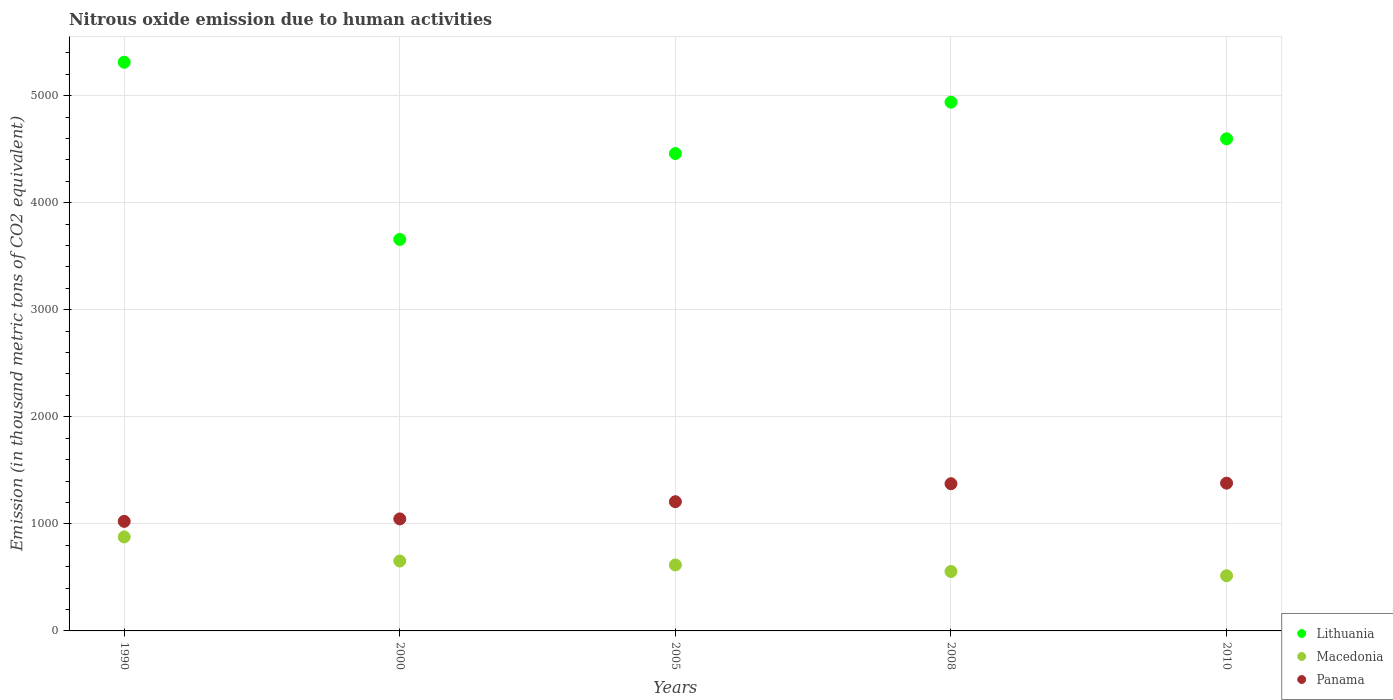Is the number of dotlines equal to the number of legend labels?
Give a very brief answer. Yes. What is the amount of nitrous oxide emitted in Panama in 2008?
Provide a short and direct response. 1375. Across all years, what is the maximum amount of nitrous oxide emitted in Macedonia?
Offer a terse response. 877.9. Across all years, what is the minimum amount of nitrous oxide emitted in Lithuania?
Keep it short and to the point. 3657. In which year was the amount of nitrous oxide emitted in Macedonia maximum?
Give a very brief answer. 1990. In which year was the amount of nitrous oxide emitted in Lithuania minimum?
Your response must be concise. 2000. What is the total amount of nitrous oxide emitted in Panama in the graph?
Your answer should be very brief. 6032.2. What is the difference between the amount of nitrous oxide emitted in Panama in 1990 and the amount of nitrous oxide emitted in Macedonia in 2010?
Your answer should be very brief. 507.7. What is the average amount of nitrous oxide emitted in Panama per year?
Your response must be concise. 1206.44. In the year 2000, what is the difference between the amount of nitrous oxide emitted in Lithuania and amount of nitrous oxide emitted in Macedonia?
Provide a succinct answer. 3004.2. What is the ratio of the amount of nitrous oxide emitted in Macedonia in 2000 to that in 2008?
Give a very brief answer. 1.18. Is the amount of nitrous oxide emitted in Macedonia in 1990 less than that in 2010?
Offer a terse response. No. What is the difference between the highest and the second highest amount of nitrous oxide emitted in Panama?
Your answer should be compact. 5.4. What is the difference between the highest and the lowest amount of nitrous oxide emitted in Macedonia?
Your answer should be compact. 362.3. In how many years, is the amount of nitrous oxide emitted in Panama greater than the average amount of nitrous oxide emitted in Panama taken over all years?
Your response must be concise. 3. Is it the case that in every year, the sum of the amount of nitrous oxide emitted in Macedonia and amount of nitrous oxide emitted in Panama  is greater than the amount of nitrous oxide emitted in Lithuania?
Your answer should be very brief. No. Is the amount of nitrous oxide emitted in Panama strictly greater than the amount of nitrous oxide emitted in Macedonia over the years?
Your response must be concise. Yes. How many dotlines are there?
Offer a terse response. 3. Does the graph contain any zero values?
Offer a very short reply. No. Does the graph contain grids?
Provide a succinct answer. Yes. How many legend labels are there?
Your response must be concise. 3. How are the legend labels stacked?
Your answer should be very brief. Vertical. What is the title of the graph?
Keep it short and to the point. Nitrous oxide emission due to human activities. What is the label or title of the Y-axis?
Your answer should be compact. Emission (in thousand metric tons of CO2 equivalent). What is the Emission (in thousand metric tons of CO2 equivalent) of Lithuania in 1990?
Your answer should be very brief. 5312.1. What is the Emission (in thousand metric tons of CO2 equivalent) in Macedonia in 1990?
Make the answer very short. 877.9. What is the Emission (in thousand metric tons of CO2 equivalent) in Panama in 1990?
Your answer should be very brief. 1023.3. What is the Emission (in thousand metric tons of CO2 equivalent) in Lithuania in 2000?
Keep it short and to the point. 3657. What is the Emission (in thousand metric tons of CO2 equivalent) of Macedonia in 2000?
Make the answer very short. 652.8. What is the Emission (in thousand metric tons of CO2 equivalent) in Panama in 2000?
Provide a succinct answer. 1046.4. What is the Emission (in thousand metric tons of CO2 equivalent) in Lithuania in 2005?
Provide a short and direct response. 4459.4. What is the Emission (in thousand metric tons of CO2 equivalent) of Macedonia in 2005?
Make the answer very short. 616.1. What is the Emission (in thousand metric tons of CO2 equivalent) of Panama in 2005?
Make the answer very short. 1207.1. What is the Emission (in thousand metric tons of CO2 equivalent) in Lithuania in 2008?
Keep it short and to the point. 4939.2. What is the Emission (in thousand metric tons of CO2 equivalent) in Macedonia in 2008?
Offer a very short reply. 555.1. What is the Emission (in thousand metric tons of CO2 equivalent) in Panama in 2008?
Your answer should be very brief. 1375. What is the Emission (in thousand metric tons of CO2 equivalent) in Lithuania in 2010?
Make the answer very short. 4596.8. What is the Emission (in thousand metric tons of CO2 equivalent) in Macedonia in 2010?
Offer a very short reply. 515.6. What is the Emission (in thousand metric tons of CO2 equivalent) of Panama in 2010?
Your answer should be very brief. 1380.4. Across all years, what is the maximum Emission (in thousand metric tons of CO2 equivalent) in Lithuania?
Make the answer very short. 5312.1. Across all years, what is the maximum Emission (in thousand metric tons of CO2 equivalent) in Macedonia?
Your response must be concise. 877.9. Across all years, what is the maximum Emission (in thousand metric tons of CO2 equivalent) in Panama?
Keep it short and to the point. 1380.4. Across all years, what is the minimum Emission (in thousand metric tons of CO2 equivalent) of Lithuania?
Provide a short and direct response. 3657. Across all years, what is the minimum Emission (in thousand metric tons of CO2 equivalent) in Macedonia?
Your response must be concise. 515.6. Across all years, what is the minimum Emission (in thousand metric tons of CO2 equivalent) in Panama?
Provide a short and direct response. 1023.3. What is the total Emission (in thousand metric tons of CO2 equivalent) of Lithuania in the graph?
Your answer should be compact. 2.30e+04. What is the total Emission (in thousand metric tons of CO2 equivalent) of Macedonia in the graph?
Offer a terse response. 3217.5. What is the total Emission (in thousand metric tons of CO2 equivalent) in Panama in the graph?
Offer a terse response. 6032.2. What is the difference between the Emission (in thousand metric tons of CO2 equivalent) of Lithuania in 1990 and that in 2000?
Offer a very short reply. 1655.1. What is the difference between the Emission (in thousand metric tons of CO2 equivalent) in Macedonia in 1990 and that in 2000?
Provide a succinct answer. 225.1. What is the difference between the Emission (in thousand metric tons of CO2 equivalent) in Panama in 1990 and that in 2000?
Offer a terse response. -23.1. What is the difference between the Emission (in thousand metric tons of CO2 equivalent) in Lithuania in 1990 and that in 2005?
Provide a succinct answer. 852.7. What is the difference between the Emission (in thousand metric tons of CO2 equivalent) of Macedonia in 1990 and that in 2005?
Offer a very short reply. 261.8. What is the difference between the Emission (in thousand metric tons of CO2 equivalent) of Panama in 1990 and that in 2005?
Offer a terse response. -183.8. What is the difference between the Emission (in thousand metric tons of CO2 equivalent) of Lithuania in 1990 and that in 2008?
Offer a terse response. 372.9. What is the difference between the Emission (in thousand metric tons of CO2 equivalent) of Macedonia in 1990 and that in 2008?
Ensure brevity in your answer.  322.8. What is the difference between the Emission (in thousand metric tons of CO2 equivalent) in Panama in 1990 and that in 2008?
Your response must be concise. -351.7. What is the difference between the Emission (in thousand metric tons of CO2 equivalent) of Lithuania in 1990 and that in 2010?
Provide a short and direct response. 715.3. What is the difference between the Emission (in thousand metric tons of CO2 equivalent) in Macedonia in 1990 and that in 2010?
Offer a terse response. 362.3. What is the difference between the Emission (in thousand metric tons of CO2 equivalent) in Panama in 1990 and that in 2010?
Ensure brevity in your answer.  -357.1. What is the difference between the Emission (in thousand metric tons of CO2 equivalent) of Lithuania in 2000 and that in 2005?
Provide a short and direct response. -802.4. What is the difference between the Emission (in thousand metric tons of CO2 equivalent) in Macedonia in 2000 and that in 2005?
Your answer should be very brief. 36.7. What is the difference between the Emission (in thousand metric tons of CO2 equivalent) in Panama in 2000 and that in 2005?
Provide a succinct answer. -160.7. What is the difference between the Emission (in thousand metric tons of CO2 equivalent) in Lithuania in 2000 and that in 2008?
Your answer should be very brief. -1282.2. What is the difference between the Emission (in thousand metric tons of CO2 equivalent) in Macedonia in 2000 and that in 2008?
Your answer should be very brief. 97.7. What is the difference between the Emission (in thousand metric tons of CO2 equivalent) of Panama in 2000 and that in 2008?
Offer a terse response. -328.6. What is the difference between the Emission (in thousand metric tons of CO2 equivalent) in Lithuania in 2000 and that in 2010?
Provide a short and direct response. -939.8. What is the difference between the Emission (in thousand metric tons of CO2 equivalent) in Macedonia in 2000 and that in 2010?
Your response must be concise. 137.2. What is the difference between the Emission (in thousand metric tons of CO2 equivalent) in Panama in 2000 and that in 2010?
Make the answer very short. -334. What is the difference between the Emission (in thousand metric tons of CO2 equivalent) of Lithuania in 2005 and that in 2008?
Make the answer very short. -479.8. What is the difference between the Emission (in thousand metric tons of CO2 equivalent) in Panama in 2005 and that in 2008?
Keep it short and to the point. -167.9. What is the difference between the Emission (in thousand metric tons of CO2 equivalent) in Lithuania in 2005 and that in 2010?
Keep it short and to the point. -137.4. What is the difference between the Emission (in thousand metric tons of CO2 equivalent) in Macedonia in 2005 and that in 2010?
Provide a short and direct response. 100.5. What is the difference between the Emission (in thousand metric tons of CO2 equivalent) in Panama in 2005 and that in 2010?
Ensure brevity in your answer.  -173.3. What is the difference between the Emission (in thousand metric tons of CO2 equivalent) in Lithuania in 2008 and that in 2010?
Your answer should be compact. 342.4. What is the difference between the Emission (in thousand metric tons of CO2 equivalent) in Macedonia in 2008 and that in 2010?
Ensure brevity in your answer.  39.5. What is the difference between the Emission (in thousand metric tons of CO2 equivalent) in Panama in 2008 and that in 2010?
Give a very brief answer. -5.4. What is the difference between the Emission (in thousand metric tons of CO2 equivalent) of Lithuania in 1990 and the Emission (in thousand metric tons of CO2 equivalent) of Macedonia in 2000?
Your answer should be very brief. 4659.3. What is the difference between the Emission (in thousand metric tons of CO2 equivalent) in Lithuania in 1990 and the Emission (in thousand metric tons of CO2 equivalent) in Panama in 2000?
Offer a very short reply. 4265.7. What is the difference between the Emission (in thousand metric tons of CO2 equivalent) in Macedonia in 1990 and the Emission (in thousand metric tons of CO2 equivalent) in Panama in 2000?
Keep it short and to the point. -168.5. What is the difference between the Emission (in thousand metric tons of CO2 equivalent) of Lithuania in 1990 and the Emission (in thousand metric tons of CO2 equivalent) of Macedonia in 2005?
Your response must be concise. 4696. What is the difference between the Emission (in thousand metric tons of CO2 equivalent) in Lithuania in 1990 and the Emission (in thousand metric tons of CO2 equivalent) in Panama in 2005?
Offer a terse response. 4105. What is the difference between the Emission (in thousand metric tons of CO2 equivalent) in Macedonia in 1990 and the Emission (in thousand metric tons of CO2 equivalent) in Panama in 2005?
Offer a very short reply. -329.2. What is the difference between the Emission (in thousand metric tons of CO2 equivalent) in Lithuania in 1990 and the Emission (in thousand metric tons of CO2 equivalent) in Macedonia in 2008?
Your response must be concise. 4757. What is the difference between the Emission (in thousand metric tons of CO2 equivalent) in Lithuania in 1990 and the Emission (in thousand metric tons of CO2 equivalent) in Panama in 2008?
Ensure brevity in your answer.  3937.1. What is the difference between the Emission (in thousand metric tons of CO2 equivalent) in Macedonia in 1990 and the Emission (in thousand metric tons of CO2 equivalent) in Panama in 2008?
Make the answer very short. -497.1. What is the difference between the Emission (in thousand metric tons of CO2 equivalent) of Lithuania in 1990 and the Emission (in thousand metric tons of CO2 equivalent) of Macedonia in 2010?
Make the answer very short. 4796.5. What is the difference between the Emission (in thousand metric tons of CO2 equivalent) of Lithuania in 1990 and the Emission (in thousand metric tons of CO2 equivalent) of Panama in 2010?
Your answer should be very brief. 3931.7. What is the difference between the Emission (in thousand metric tons of CO2 equivalent) of Macedonia in 1990 and the Emission (in thousand metric tons of CO2 equivalent) of Panama in 2010?
Give a very brief answer. -502.5. What is the difference between the Emission (in thousand metric tons of CO2 equivalent) of Lithuania in 2000 and the Emission (in thousand metric tons of CO2 equivalent) of Macedonia in 2005?
Your response must be concise. 3040.9. What is the difference between the Emission (in thousand metric tons of CO2 equivalent) of Lithuania in 2000 and the Emission (in thousand metric tons of CO2 equivalent) of Panama in 2005?
Offer a very short reply. 2449.9. What is the difference between the Emission (in thousand metric tons of CO2 equivalent) in Macedonia in 2000 and the Emission (in thousand metric tons of CO2 equivalent) in Panama in 2005?
Offer a very short reply. -554.3. What is the difference between the Emission (in thousand metric tons of CO2 equivalent) in Lithuania in 2000 and the Emission (in thousand metric tons of CO2 equivalent) in Macedonia in 2008?
Offer a terse response. 3101.9. What is the difference between the Emission (in thousand metric tons of CO2 equivalent) in Lithuania in 2000 and the Emission (in thousand metric tons of CO2 equivalent) in Panama in 2008?
Your answer should be very brief. 2282. What is the difference between the Emission (in thousand metric tons of CO2 equivalent) of Macedonia in 2000 and the Emission (in thousand metric tons of CO2 equivalent) of Panama in 2008?
Provide a succinct answer. -722.2. What is the difference between the Emission (in thousand metric tons of CO2 equivalent) in Lithuania in 2000 and the Emission (in thousand metric tons of CO2 equivalent) in Macedonia in 2010?
Ensure brevity in your answer.  3141.4. What is the difference between the Emission (in thousand metric tons of CO2 equivalent) in Lithuania in 2000 and the Emission (in thousand metric tons of CO2 equivalent) in Panama in 2010?
Provide a short and direct response. 2276.6. What is the difference between the Emission (in thousand metric tons of CO2 equivalent) in Macedonia in 2000 and the Emission (in thousand metric tons of CO2 equivalent) in Panama in 2010?
Provide a short and direct response. -727.6. What is the difference between the Emission (in thousand metric tons of CO2 equivalent) of Lithuania in 2005 and the Emission (in thousand metric tons of CO2 equivalent) of Macedonia in 2008?
Provide a succinct answer. 3904.3. What is the difference between the Emission (in thousand metric tons of CO2 equivalent) in Lithuania in 2005 and the Emission (in thousand metric tons of CO2 equivalent) in Panama in 2008?
Ensure brevity in your answer.  3084.4. What is the difference between the Emission (in thousand metric tons of CO2 equivalent) of Macedonia in 2005 and the Emission (in thousand metric tons of CO2 equivalent) of Panama in 2008?
Provide a short and direct response. -758.9. What is the difference between the Emission (in thousand metric tons of CO2 equivalent) of Lithuania in 2005 and the Emission (in thousand metric tons of CO2 equivalent) of Macedonia in 2010?
Your answer should be compact. 3943.8. What is the difference between the Emission (in thousand metric tons of CO2 equivalent) of Lithuania in 2005 and the Emission (in thousand metric tons of CO2 equivalent) of Panama in 2010?
Keep it short and to the point. 3079. What is the difference between the Emission (in thousand metric tons of CO2 equivalent) of Macedonia in 2005 and the Emission (in thousand metric tons of CO2 equivalent) of Panama in 2010?
Make the answer very short. -764.3. What is the difference between the Emission (in thousand metric tons of CO2 equivalent) in Lithuania in 2008 and the Emission (in thousand metric tons of CO2 equivalent) in Macedonia in 2010?
Your answer should be very brief. 4423.6. What is the difference between the Emission (in thousand metric tons of CO2 equivalent) of Lithuania in 2008 and the Emission (in thousand metric tons of CO2 equivalent) of Panama in 2010?
Give a very brief answer. 3558.8. What is the difference between the Emission (in thousand metric tons of CO2 equivalent) in Macedonia in 2008 and the Emission (in thousand metric tons of CO2 equivalent) in Panama in 2010?
Your answer should be very brief. -825.3. What is the average Emission (in thousand metric tons of CO2 equivalent) of Lithuania per year?
Provide a short and direct response. 4592.9. What is the average Emission (in thousand metric tons of CO2 equivalent) in Macedonia per year?
Keep it short and to the point. 643.5. What is the average Emission (in thousand metric tons of CO2 equivalent) of Panama per year?
Your response must be concise. 1206.44. In the year 1990, what is the difference between the Emission (in thousand metric tons of CO2 equivalent) in Lithuania and Emission (in thousand metric tons of CO2 equivalent) in Macedonia?
Keep it short and to the point. 4434.2. In the year 1990, what is the difference between the Emission (in thousand metric tons of CO2 equivalent) in Lithuania and Emission (in thousand metric tons of CO2 equivalent) in Panama?
Your answer should be compact. 4288.8. In the year 1990, what is the difference between the Emission (in thousand metric tons of CO2 equivalent) of Macedonia and Emission (in thousand metric tons of CO2 equivalent) of Panama?
Offer a very short reply. -145.4. In the year 2000, what is the difference between the Emission (in thousand metric tons of CO2 equivalent) of Lithuania and Emission (in thousand metric tons of CO2 equivalent) of Macedonia?
Make the answer very short. 3004.2. In the year 2000, what is the difference between the Emission (in thousand metric tons of CO2 equivalent) in Lithuania and Emission (in thousand metric tons of CO2 equivalent) in Panama?
Ensure brevity in your answer.  2610.6. In the year 2000, what is the difference between the Emission (in thousand metric tons of CO2 equivalent) of Macedonia and Emission (in thousand metric tons of CO2 equivalent) of Panama?
Your answer should be compact. -393.6. In the year 2005, what is the difference between the Emission (in thousand metric tons of CO2 equivalent) of Lithuania and Emission (in thousand metric tons of CO2 equivalent) of Macedonia?
Provide a short and direct response. 3843.3. In the year 2005, what is the difference between the Emission (in thousand metric tons of CO2 equivalent) in Lithuania and Emission (in thousand metric tons of CO2 equivalent) in Panama?
Offer a very short reply. 3252.3. In the year 2005, what is the difference between the Emission (in thousand metric tons of CO2 equivalent) in Macedonia and Emission (in thousand metric tons of CO2 equivalent) in Panama?
Give a very brief answer. -591. In the year 2008, what is the difference between the Emission (in thousand metric tons of CO2 equivalent) in Lithuania and Emission (in thousand metric tons of CO2 equivalent) in Macedonia?
Your response must be concise. 4384.1. In the year 2008, what is the difference between the Emission (in thousand metric tons of CO2 equivalent) of Lithuania and Emission (in thousand metric tons of CO2 equivalent) of Panama?
Offer a very short reply. 3564.2. In the year 2008, what is the difference between the Emission (in thousand metric tons of CO2 equivalent) of Macedonia and Emission (in thousand metric tons of CO2 equivalent) of Panama?
Your response must be concise. -819.9. In the year 2010, what is the difference between the Emission (in thousand metric tons of CO2 equivalent) in Lithuania and Emission (in thousand metric tons of CO2 equivalent) in Macedonia?
Your answer should be compact. 4081.2. In the year 2010, what is the difference between the Emission (in thousand metric tons of CO2 equivalent) in Lithuania and Emission (in thousand metric tons of CO2 equivalent) in Panama?
Your response must be concise. 3216.4. In the year 2010, what is the difference between the Emission (in thousand metric tons of CO2 equivalent) of Macedonia and Emission (in thousand metric tons of CO2 equivalent) of Panama?
Keep it short and to the point. -864.8. What is the ratio of the Emission (in thousand metric tons of CO2 equivalent) in Lithuania in 1990 to that in 2000?
Give a very brief answer. 1.45. What is the ratio of the Emission (in thousand metric tons of CO2 equivalent) in Macedonia in 1990 to that in 2000?
Your response must be concise. 1.34. What is the ratio of the Emission (in thousand metric tons of CO2 equivalent) in Panama in 1990 to that in 2000?
Give a very brief answer. 0.98. What is the ratio of the Emission (in thousand metric tons of CO2 equivalent) in Lithuania in 1990 to that in 2005?
Offer a very short reply. 1.19. What is the ratio of the Emission (in thousand metric tons of CO2 equivalent) in Macedonia in 1990 to that in 2005?
Offer a terse response. 1.42. What is the ratio of the Emission (in thousand metric tons of CO2 equivalent) of Panama in 1990 to that in 2005?
Provide a succinct answer. 0.85. What is the ratio of the Emission (in thousand metric tons of CO2 equivalent) in Lithuania in 1990 to that in 2008?
Your response must be concise. 1.08. What is the ratio of the Emission (in thousand metric tons of CO2 equivalent) of Macedonia in 1990 to that in 2008?
Provide a short and direct response. 1.58. What is the ratio of the Emission (in thousand metric tons of CO2 equivalent) of Panama in 1990 to that in 2008?
Offer a terse response. 0.74. What is the ratio of the Emission (in thousand metric tons of CO2 equivalent) in Lithuania in 1990 to that in 2010?
Provide a succinct answer. 1.16. What is the ratio of the Emission (in thousand metric tons of CO2 equivalent) of Macedonia in 1990 to that in 2010?
Ensure brevity in your answer.  1.7. What is the ratio of the Emission (in thousand metric tons of CO2 equivalent) of Panama in 1990 to that in 2010?
Ensure brevity in your answer.  0.74. What is the ratio of the Emission (in thousand metric tons of CO2 equivalent) in Lithuania in 2000 to that in 2005?
Offer a terse response. 0.82. What is the ratio of the Emission (in thousand metric tons of CO2 equivalent) in Macedonia in 2000 to that in 2005?
Offer a very short reply. 1.06. What is the ratio of the Emission (in thousand metric tons of CO2 equivalent) of Panama in 2000 to that in 2005?
Keep it short and to the point. 0.87. What is the ratio of the Emission (in thousand metric tons of CO2 equivalent) in Lithuania in 2000 to that in 2008?
Offer a terse response. 0.74. What is the ratio of the Emission (in thousand metric tons of CO2 equivalent) of Macedonia in 2000 to that in 2008?
Your answer should be compact. 1.18. What is the ratio of the Emission (in thousand metric tons of CO2 equivalent) of Panama in 2000 to that in 2008?
Your answer should be very brief. 0.76. What is the ratio of the Emission (in thousand metric tons of CO2 equivalent) in Lithuania in 2000 to that in 2010?
Ensure brevity in your answer.  0.8. What is the ratio of the Emission (in thousand metric tons of CO2 equivalent) in Macedonia in 2000 to that in 2010?
Make the answer very short. 1.27. What is the ratio of the Emission (in thousand metric tons of CO2 equivalent) of Panama in 2000 to that in 2010?
Your response must be concise. 0.76. What is the ratio of the Emission (in thousand metric tons of CO2 equivalent) of Lithuania in 2005 to that in 2008?
Your answer should be very brief. 0.9. What is the ratio of the Emission (in thousand metric tons of CO2 equivalent) in Macedonia in 2005 to that in 2008?
Make the answer very short. 1.11. What is the ratio of the Emission (in thousand metric tons of CO2 equivalent) of Panama in 2005 to that in 2008?
Offer a very short reply. 0.88. What is the ratio of the Emission (in thousand metric tons of CO2 equivalent) in Lithuania in 2005 to that in 2010?
Give a very brief answer. 0.97. What is the ratio of the Emission (in thousand metric tons of CO2 equivalent) in Macedonia in 2005 to that in 2010?
Give a very brief answer. 1.19. What is the ratio of the Emission (in thousand metric tons of CO2 equivalent) of Panama in 2005 to that in 2010?
Offer a terse response. 0.87. What is the ratio of the Emission (in thousand metric tons of CO2 equivalent) of Lithuania in 2008 to that in 2010?
Your response must be concise. 1.07. What is the ratio of the Emission (in thousand metric tons of CO2 equivalent) of Macedonia in 2008 to that in 2010?
Make the answer very short. 1.08. What is the ratio of the Emission (in thousand metric tons of CO2 equivalent) in Panama in 2008 to that in 2010?
Offer a very short reply. 1. What is the difference between the highest and the second highest Emission (in thousand metric tons of CO2 equivalent) in Lithuania?
Your answer should be very brief. 372.9. What is the difference between the highest and the second highest Emission (in thousand metric tons of CO2 equivalent) in Macedonia?
Offer a very short reply. 225.1. What is the difference between the highest and the second highest Emission (in thousand metric tons of CO2 equivalent) in Panama?
Give a very brief answer. 5.4. What is the difference between the highest and the lowest Emission (in thousand metric tons of CO2 equivalent) in Lithuania?
Offer a terse response. 1655.1. What is the difference between the highest and the lowest Emission (in thousand metric tons of CO2 equivalent) in Macedonia?
Your response must be concise. 362.3. What is the difference between the highest and the lowest Emission (in thousand metric tons of CO2 equivalent) in Panama?
Provide a succinct answer. 357.1. 